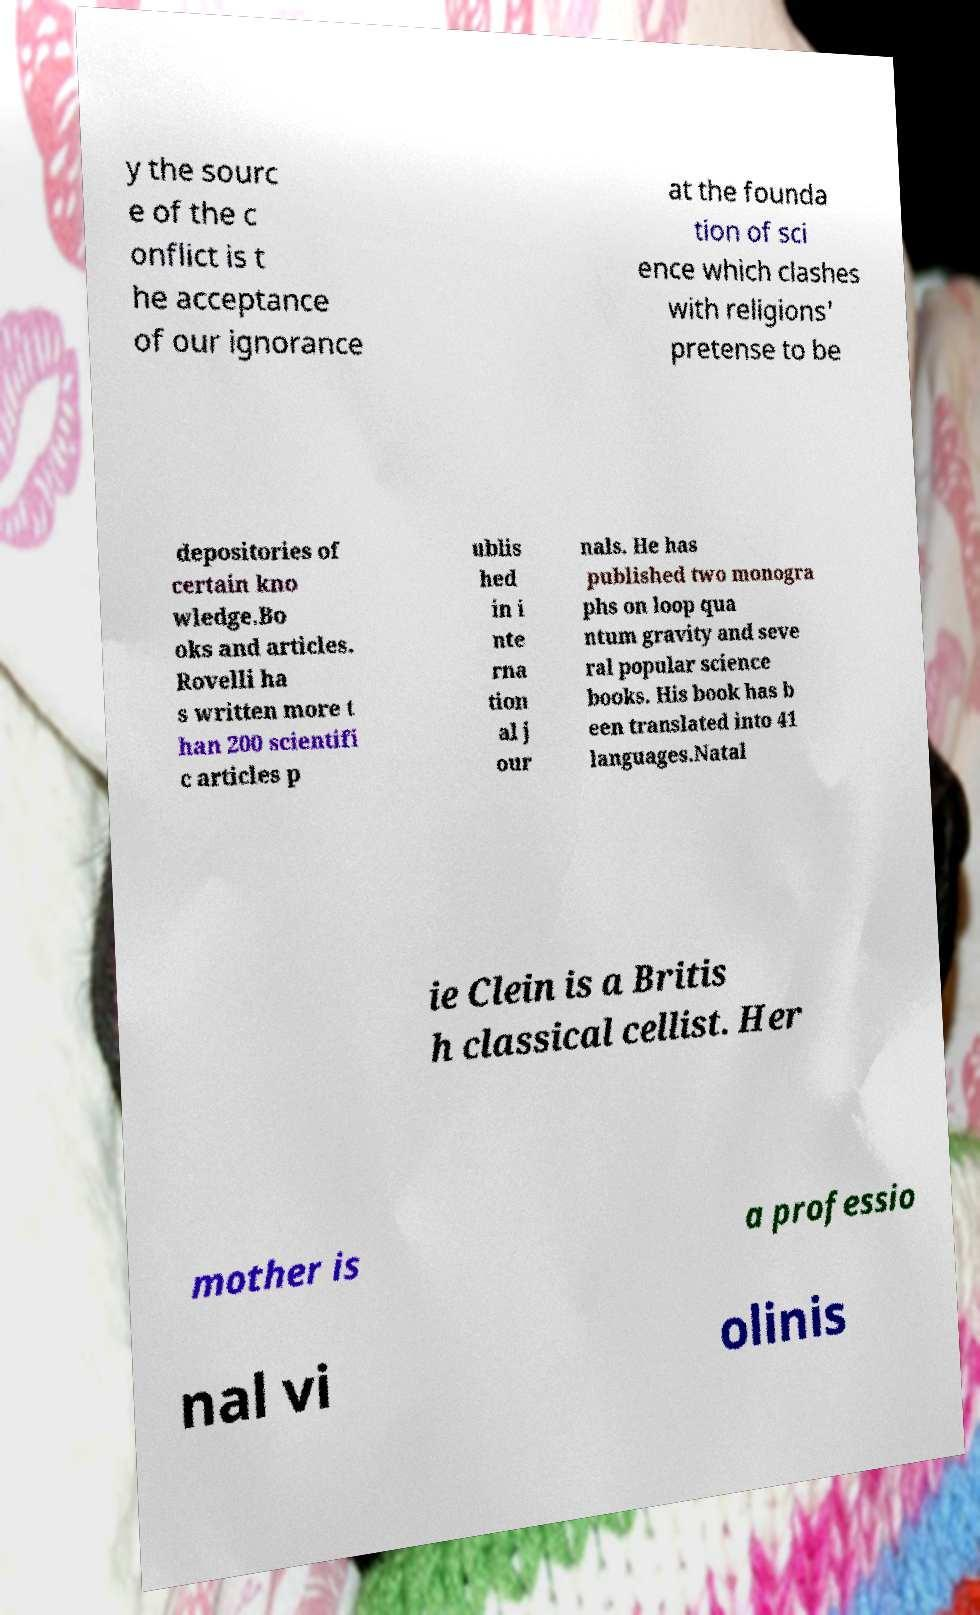Could you extract and type out the text from this image? y the sourc e of the c onflict is t he acceptance of our ignorance at the founda tion of sci ence which clashes with religions' pretense to be depositories of certain kno wledge.Bo oks and articles. Rovelli ha s written more t han 200 scientifi c articles p ublis hed in i nte rna tion al j our nals. He has published two monogra phs on loop qua ntum gravity and seve ral popular science books. His book has b een translated into 41 languages.Natal ie Clein is a Britis h classical cellist. Her mother is a professio nal vi olinis 